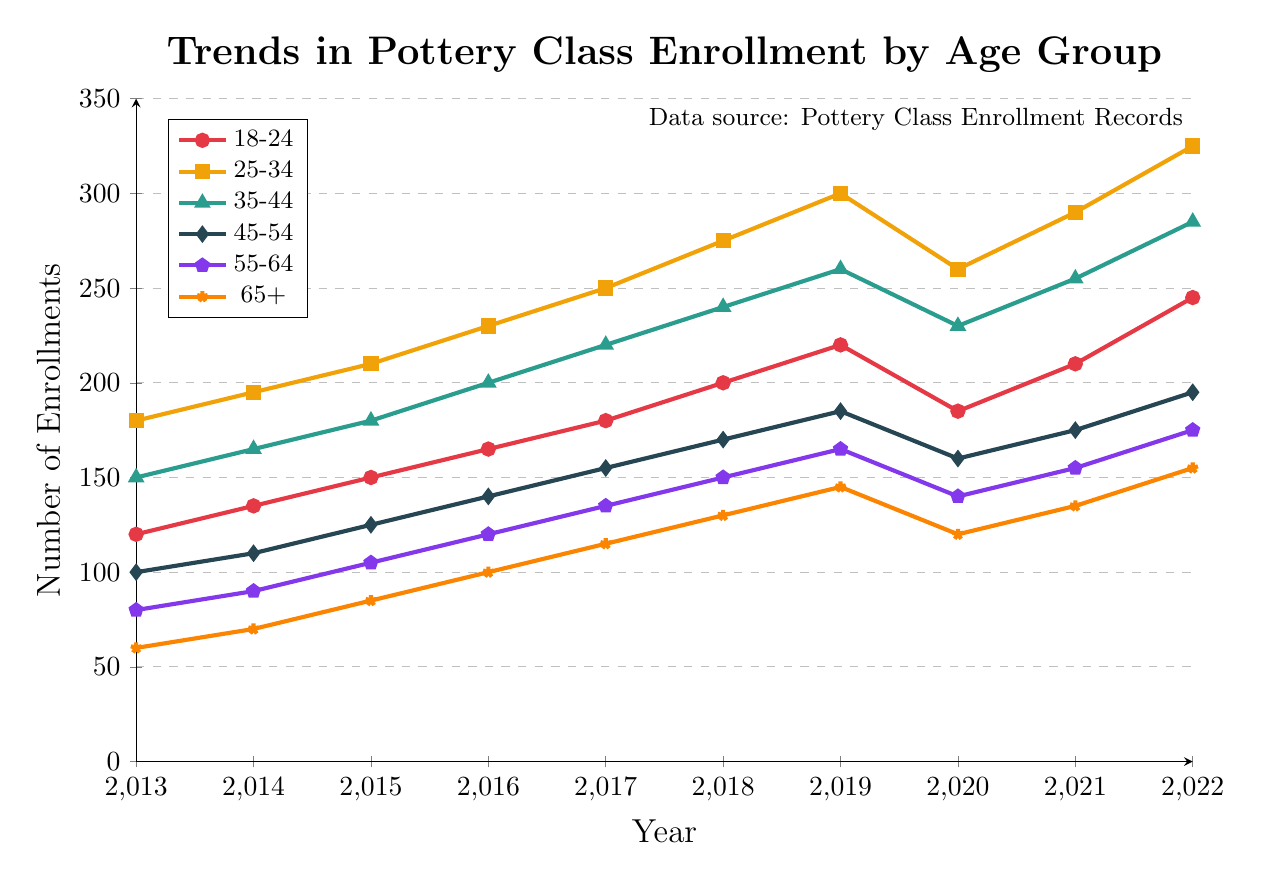How did the enrollment for the age group 18-24 change from 2019 to 2020? The chart shows that in 2019, the enrollment for the age group 18-24 was 220. In 2020, it dropped to 185. Therefore, the change is 220 - 185 = 35.
Answer: Decreased by 35 Which age group consistently had the highest enrollment throughout the decade? By visually comparing the lines representing each age group, the 25-34 age group consistently stays at the top across all the years shown.
Answer: 25-34 What is the difference in enrollments between the 18-24 and 25-34 age groups in 2022? In 2022, the enrollment for 18-24 is 245 and for 25-34 is 325. The difference is 325 - 245 = 80.
Answer: 80 Which year showed the highest enrollment for the 65+ age group, and what was the value? Looking at the 65+ line on the chart, the highest point is in 2022 with an enrollment of 155.
Answer: 2022, 155 How did the enrollment for the 45-54 age group change from 2013 to 2017? In 2013, the enrollment was 100 and in 2017, it was 155. The change is 155 - 100 = 55.
Answer: Increased by 55 Which age group showed the most significant drop in enrollments during the pandemic year 2020? By comparing the enrollment changes from 2019 to 2020 for all age groups, the 18-24 age group showed the largest drop from 220 to 185, a decrease of 35.
Answer: 18-24 What is the average enrollment for the age group 55-64 over the decade? The enrollment numbers for 55-64 each year are [80, 90, 105, 120, 135, 150, 165, 140, 155, 175]. The total is 1315, and the average is 1315 / 10 = 131.5.
Answer: 131.5 Between 2016 and 2018, which age group had the steepest increase in enrollments? By comparing the slopes between 2016 and 2018 for all age groups, the 25-34 age group had an increase from 230 to 275, which is the steepest with an increase of 45.
Answer: 25-34 Which age groups had more enrollments in 2022 than in 2013? Comparing 2022 to 2013: 
- 18-24: 245 - 120 = 125 
- 25-34: 325 - 180 = 145 
- 35-44: 285 - 150 = 135 
- 45-54: 195 - 100 = 95 
- 55-64: 175 - 80 = 95 
- 65+: 155 - 60 = 95
All age groups had increased enrollments in 2022 compared to 2013.
Answer: All age groups Which color represents the age group 65+ on the plot? By looking at the legend, the age group 65+ is represented by the color "orange" in the plot.
Answer: orange 